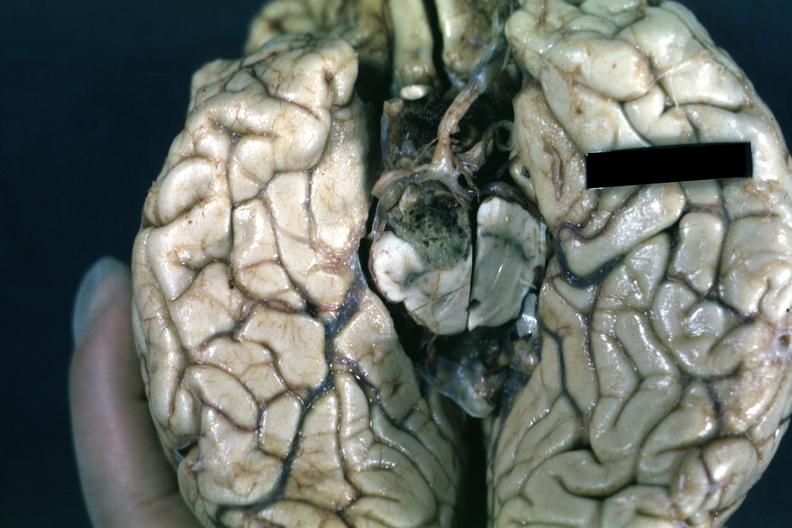s pituitary present?
Answer the question using a single word or phrase. Yes 